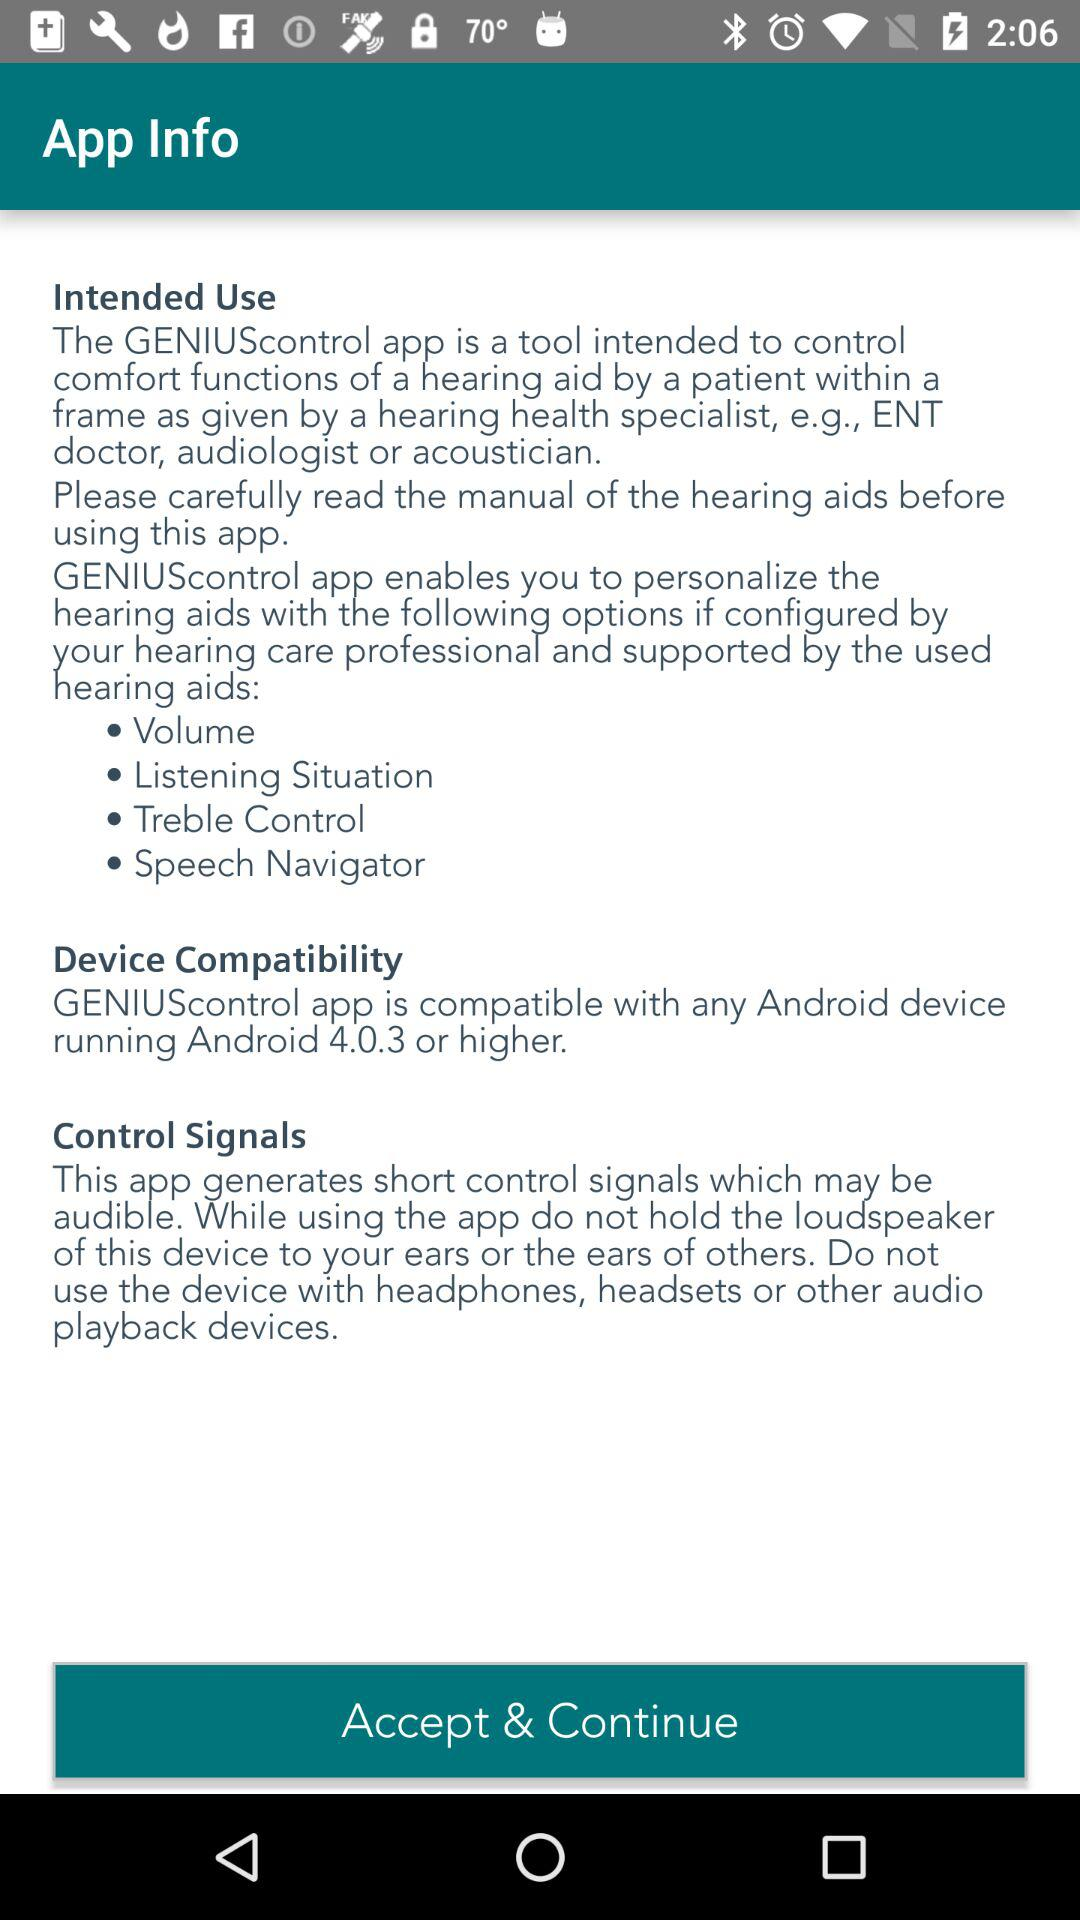How many options are available for the user to personalize their hearing aids?
Answer the question using a single word or phrase. 4 